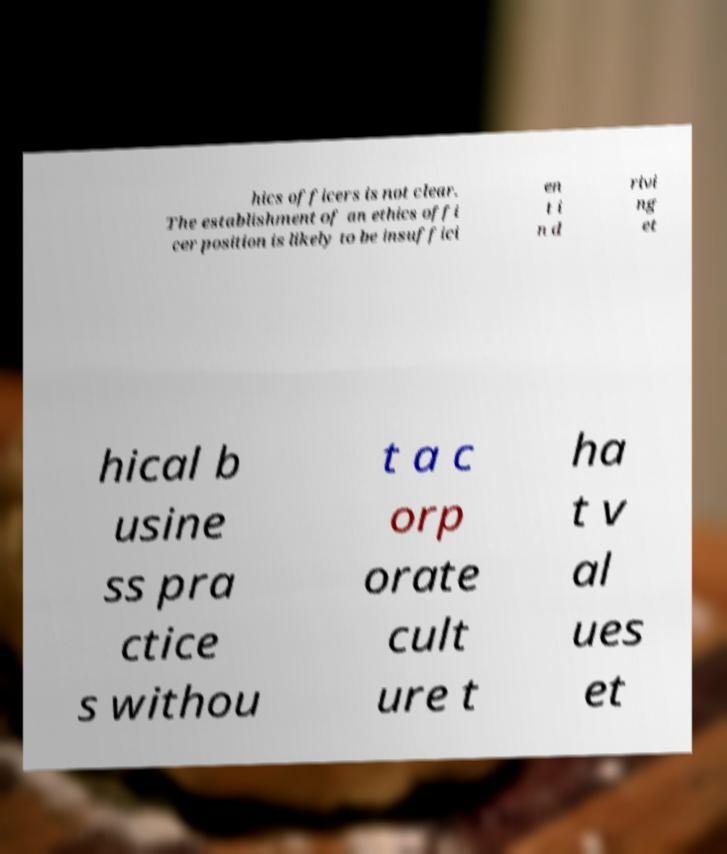Can you accurately transcribe the text from the provided image for me? hics officers is not clear. The establishment of an ethics offi cer position is likely to be insuffici en t i n d rivi ng et hical b usine ss pra ctice s withou t a c orp orate cult ure t ha t v al ues et 